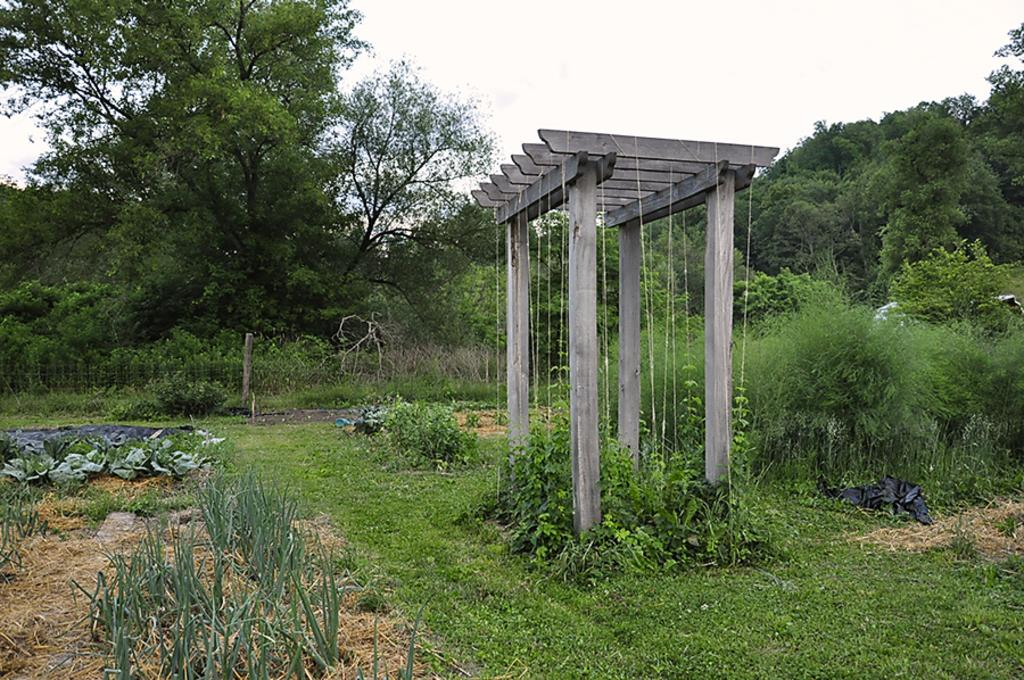What type of vegetation is present in the image? There are many trees and plants in the image. What structure can be seen in the image? There is a wooden stand in the image. What is visible at the top of the image? The sky is visible at the top of the image. Can you tell me how many hens are perched on the wooden stand in the image? There are no hens present in the image; it features trees, plants, and a wooden stand. What type of lead is used to create the wooden stand in the image? There is no mention of lead in the image, as it focuses on the vegetation and the wooden stand. 